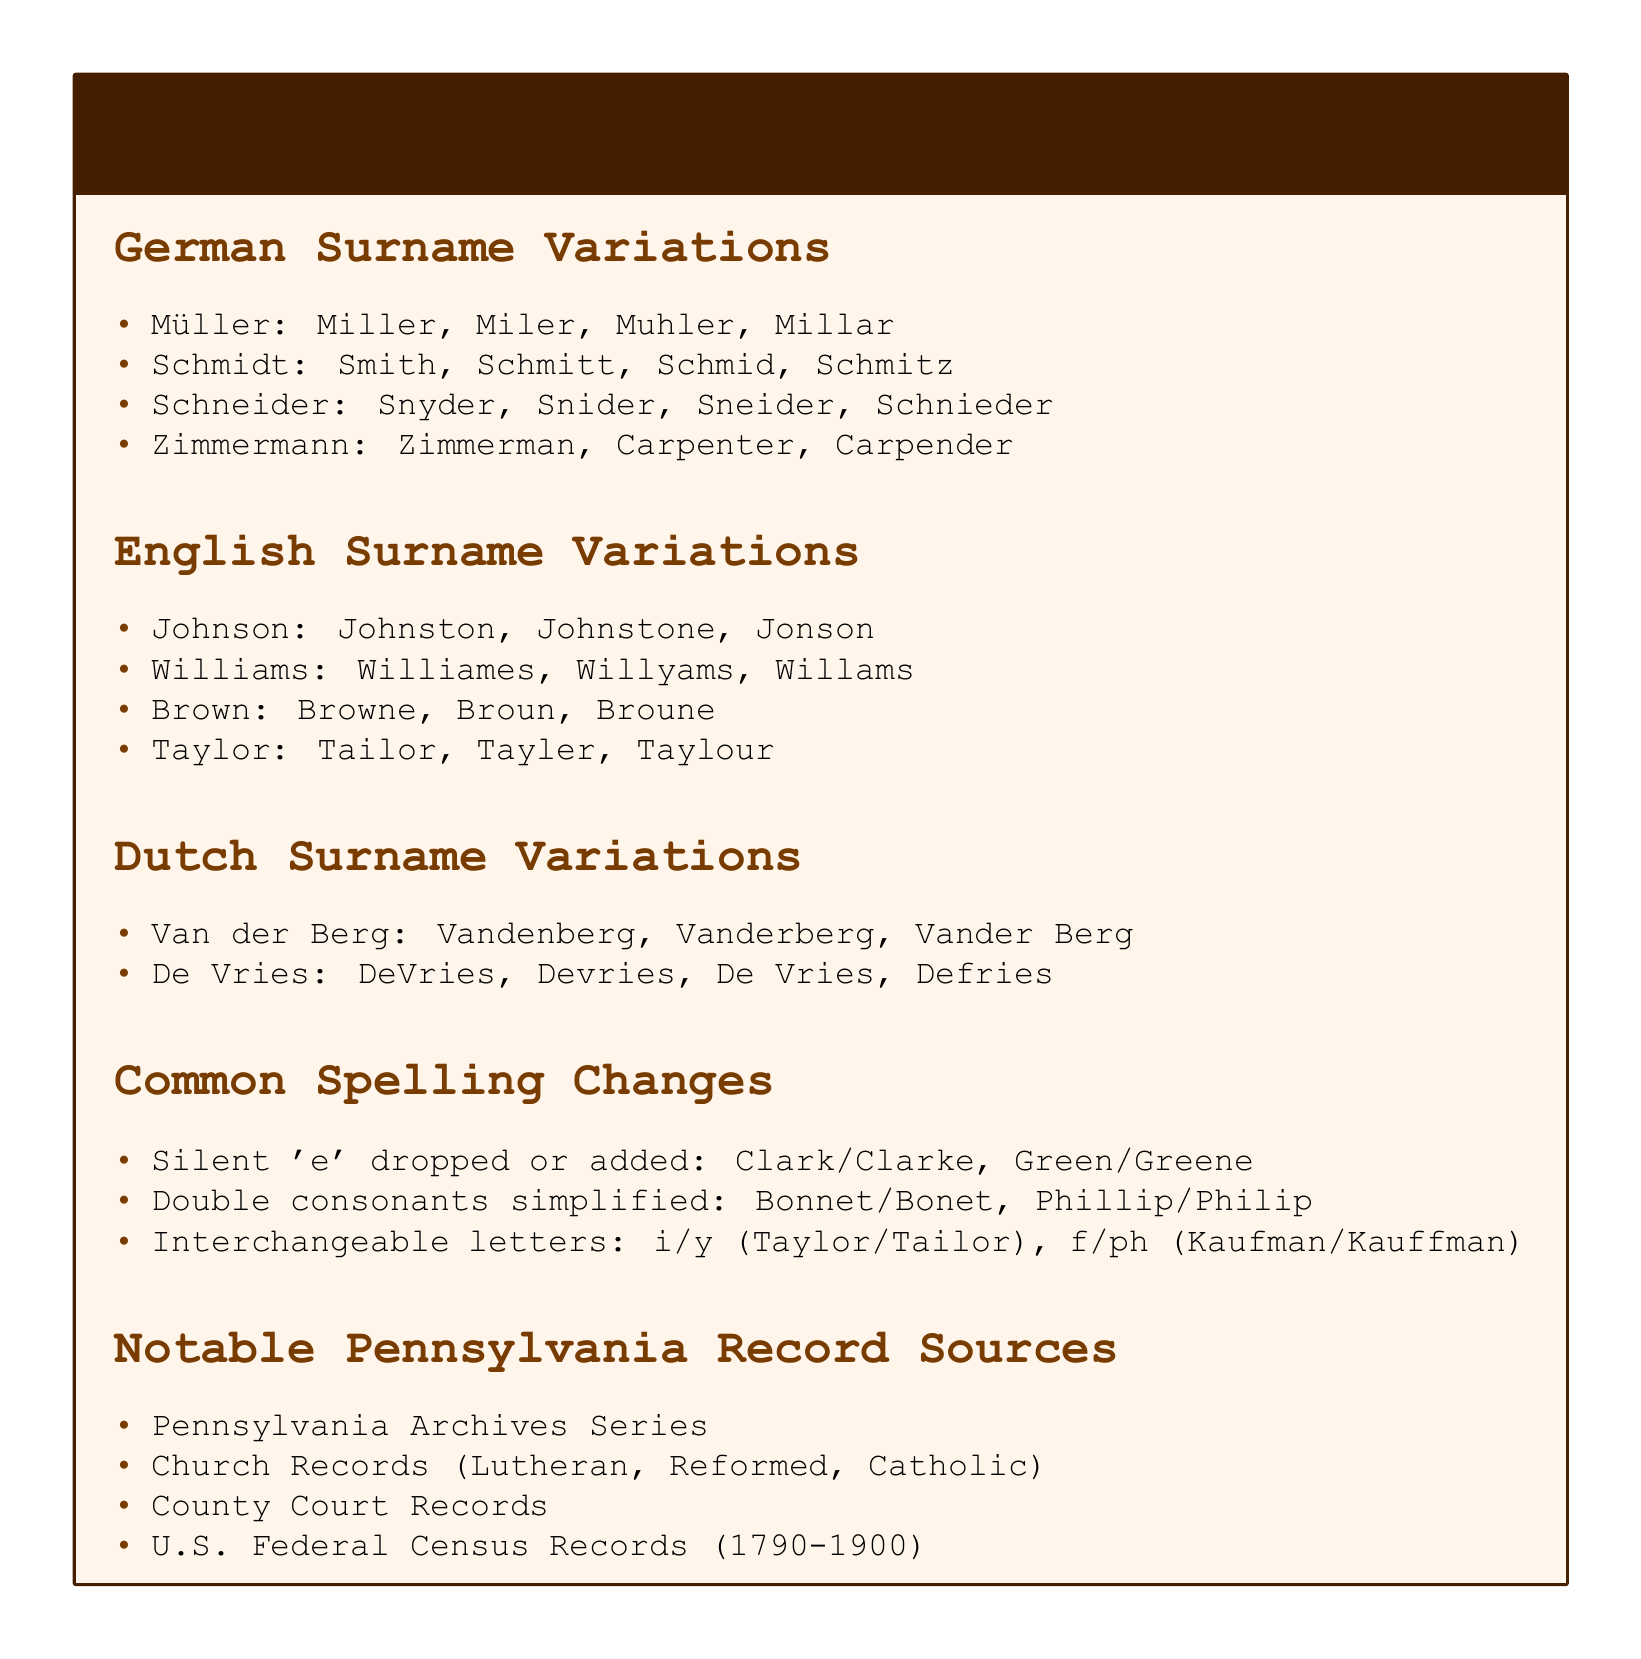What are the variations of the surname Müller? The document lists variations of Müller as Miller, Miler, Muhler, Millar.
Answer: Miller, Miler, Muhler, Millar What is one alternate spelling for the surname Taylor? The document states multiple alternate spellings for Taylor, one of which is Tailor.
Answer: Tailor Which records are notable sources for Pennsylvania family history? Notable sources mentioned include Pennsylvania Archives Series, Church Records, County Court Records, U.S. Federal Census Records.
Answer: Pennsylvania Archives Series What type of surname variations does the section contain about Johnson? The document indicates surname variations for Johnson include Johnston, Johnstone, Jonson, clearly identifying it as an English surname.
Answer: English What common spelling change involves dropping or adding a silent 'e'? The document provides examples of such spelling changes, particularly Clark/Clarke and Green/Greene, indicating this alteration.
Answer: Clark/Clarke, Green/Greene 